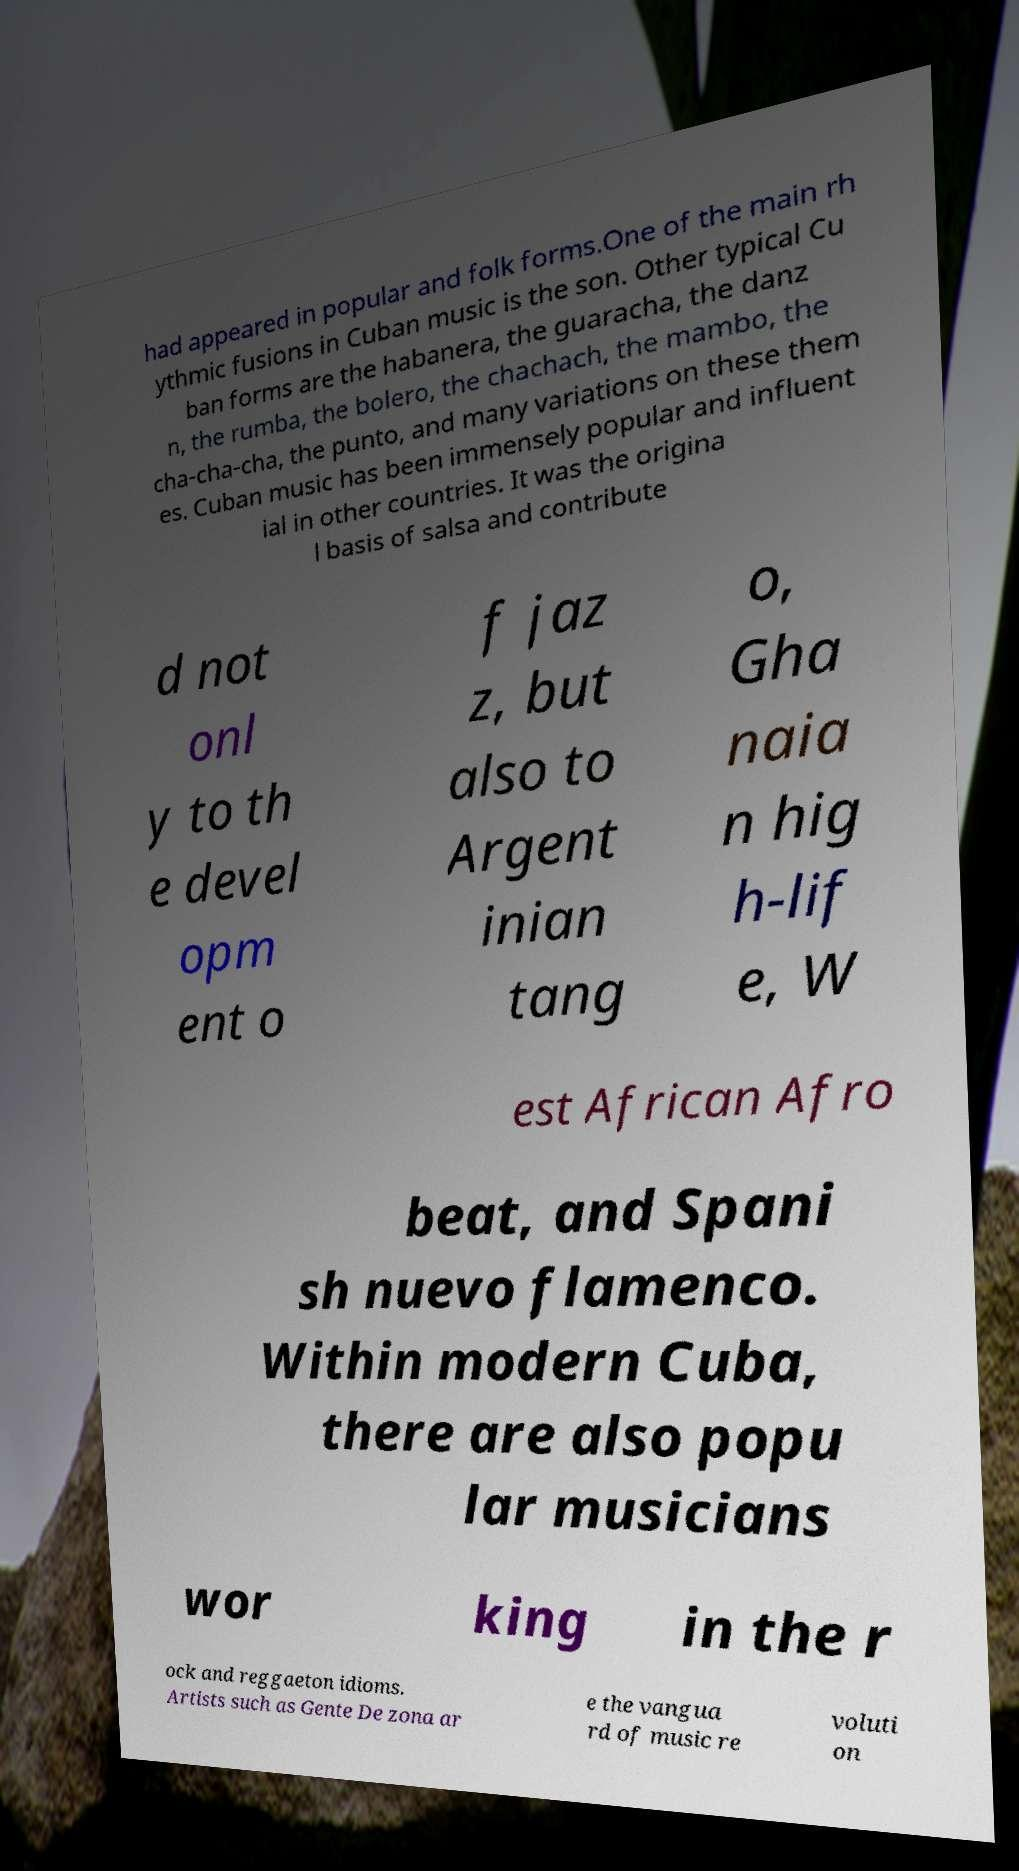For documentation purposes, I need the text within this image transcribed. Could you provide that? had appeared in popular and folk forms.One of the main rh ythmic fusions in Cuban music is the son. Other typical Cu ban forms are the habanera, the guaracha, the danz n, the rumba, the bolero, the chachach, the mambo, the cha-cha-cha, the punto, and many variations on these them es. Cuban music has been immensely popular and influent ial in other countries. It was the origina l basis of salsa and contribute d not onl y to th e devel opm ent o f jaz z, but also to Argent inian tang o, Gha naia n hig h-lif e, W est African Afro beat, and Spani sh nuevo flamenco. Within modern Cuba, there are also popu lar musicians wor king in the r ock and reggaeton idioms. Artists such as Gente De zona ar e the vangua rd of music re voluti on 